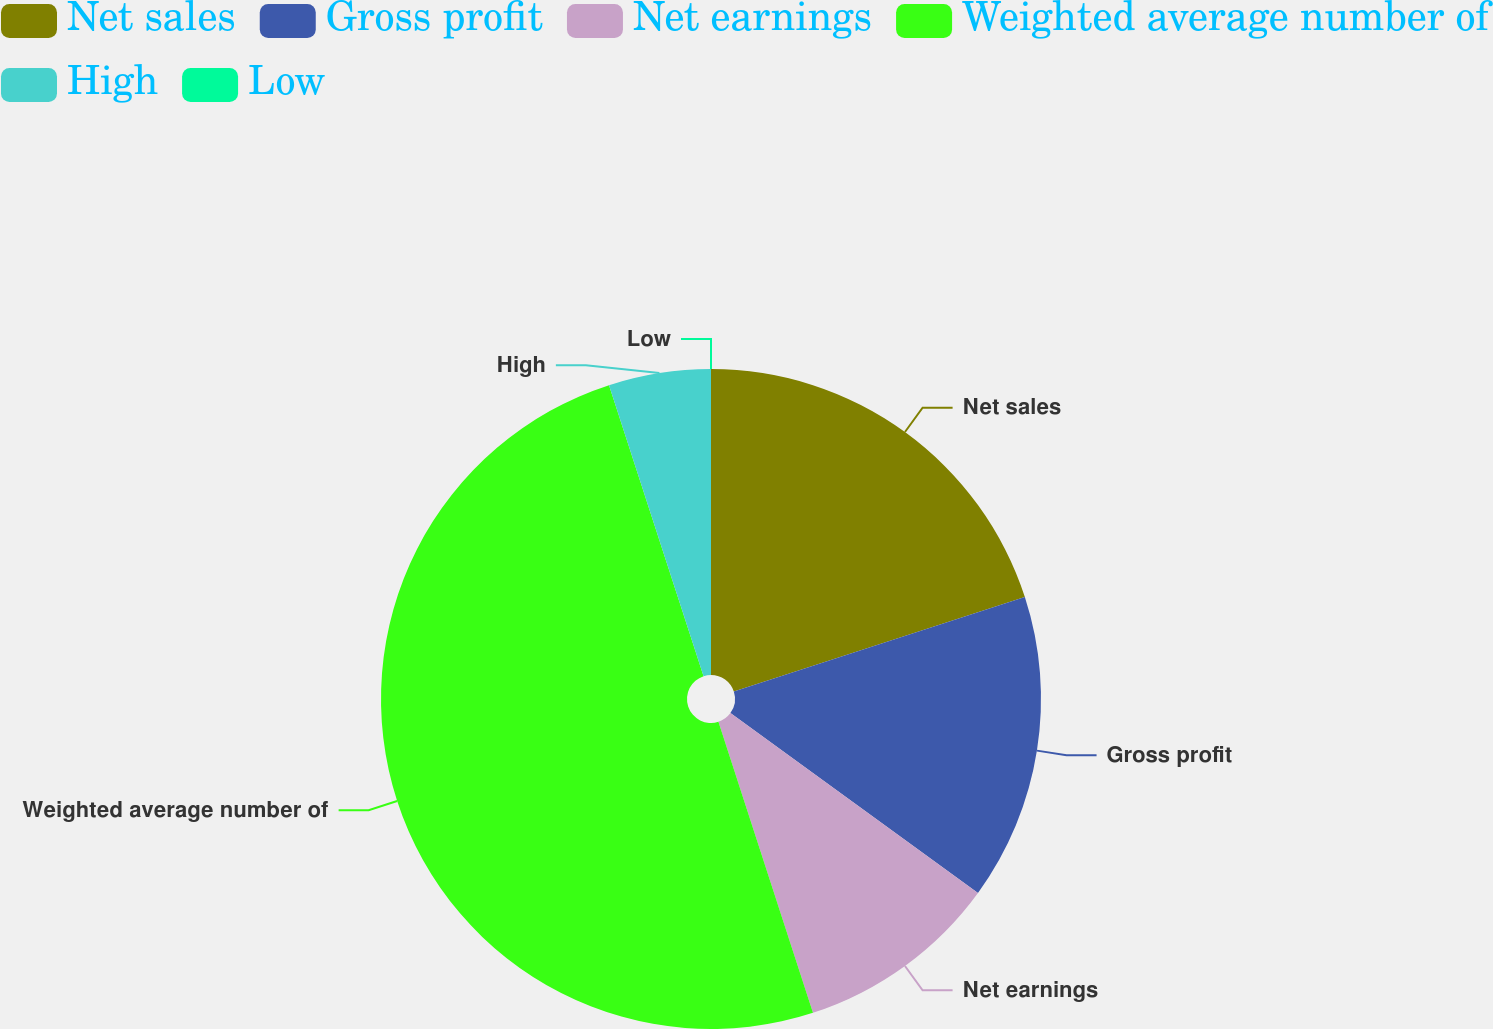Convert chart to OTSL. <chart><loc_0><loc_0><loc_500><loc_500><pie_chart><fcel>Net sales<fcel>Gross profit<fcel>Net earnings<fcel>Weighted average number of<fcel>High<fcel>Low<nl><fcel>20.0%<fcel>15.0%<fcel>10.0%<fcel>50.0%<fcel>5.0%<fcel>0.0%<nl></chart> 